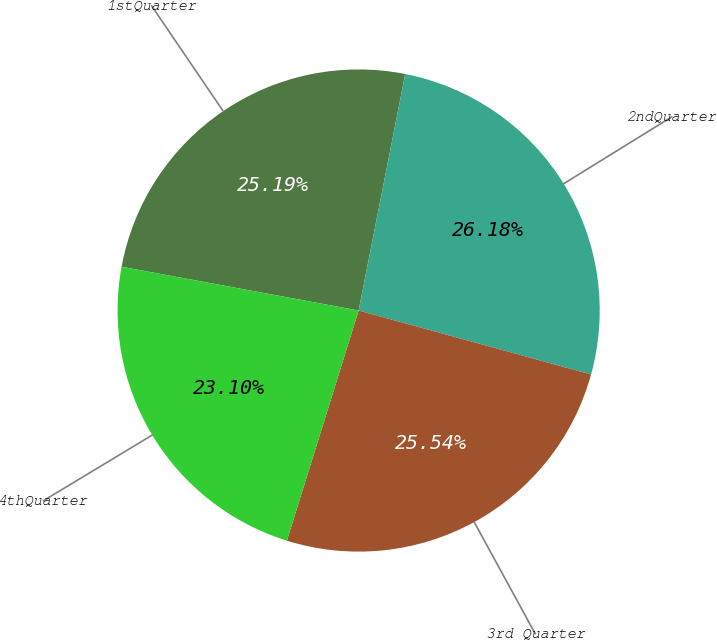<chart> <loc_0><loc_0><loc_500><loc_500><pie_chart><fcel>1stQuarter<fcel>2ndQuarter<fcel>3rd Quarter<fcel>4thQuarter<nl><fcel>25.19%<fcel>26.18%<fcel>25.54%<fcel>23.1%<nl></chart> 